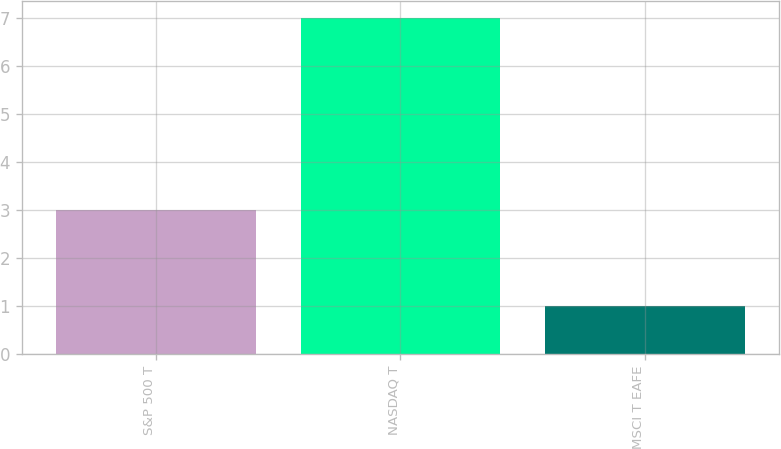Convert chart. <chart><loc_0><loc_0><loc_500><loc_500><bar_chart><fcel>S&P 500 T<fcel>NASDAQ T<fcel>MSCI T EAFE<nl><fcel>3<fcel>7<fcel>1<nl></chart> 